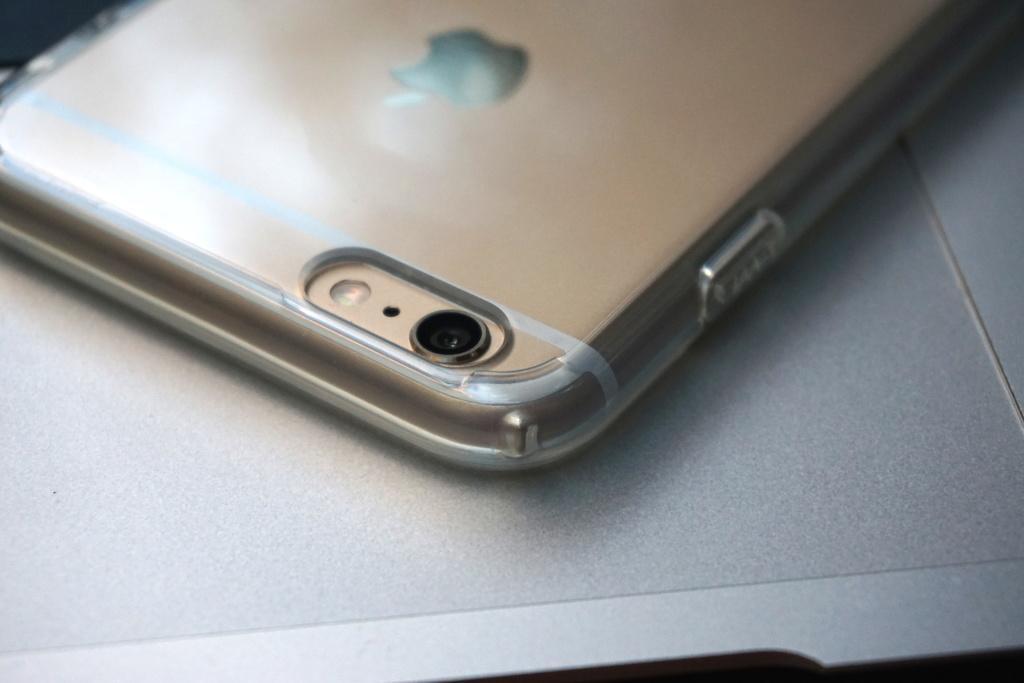Describe this image in one or two sentences. In this image we can see mobile phone placed on the table. 